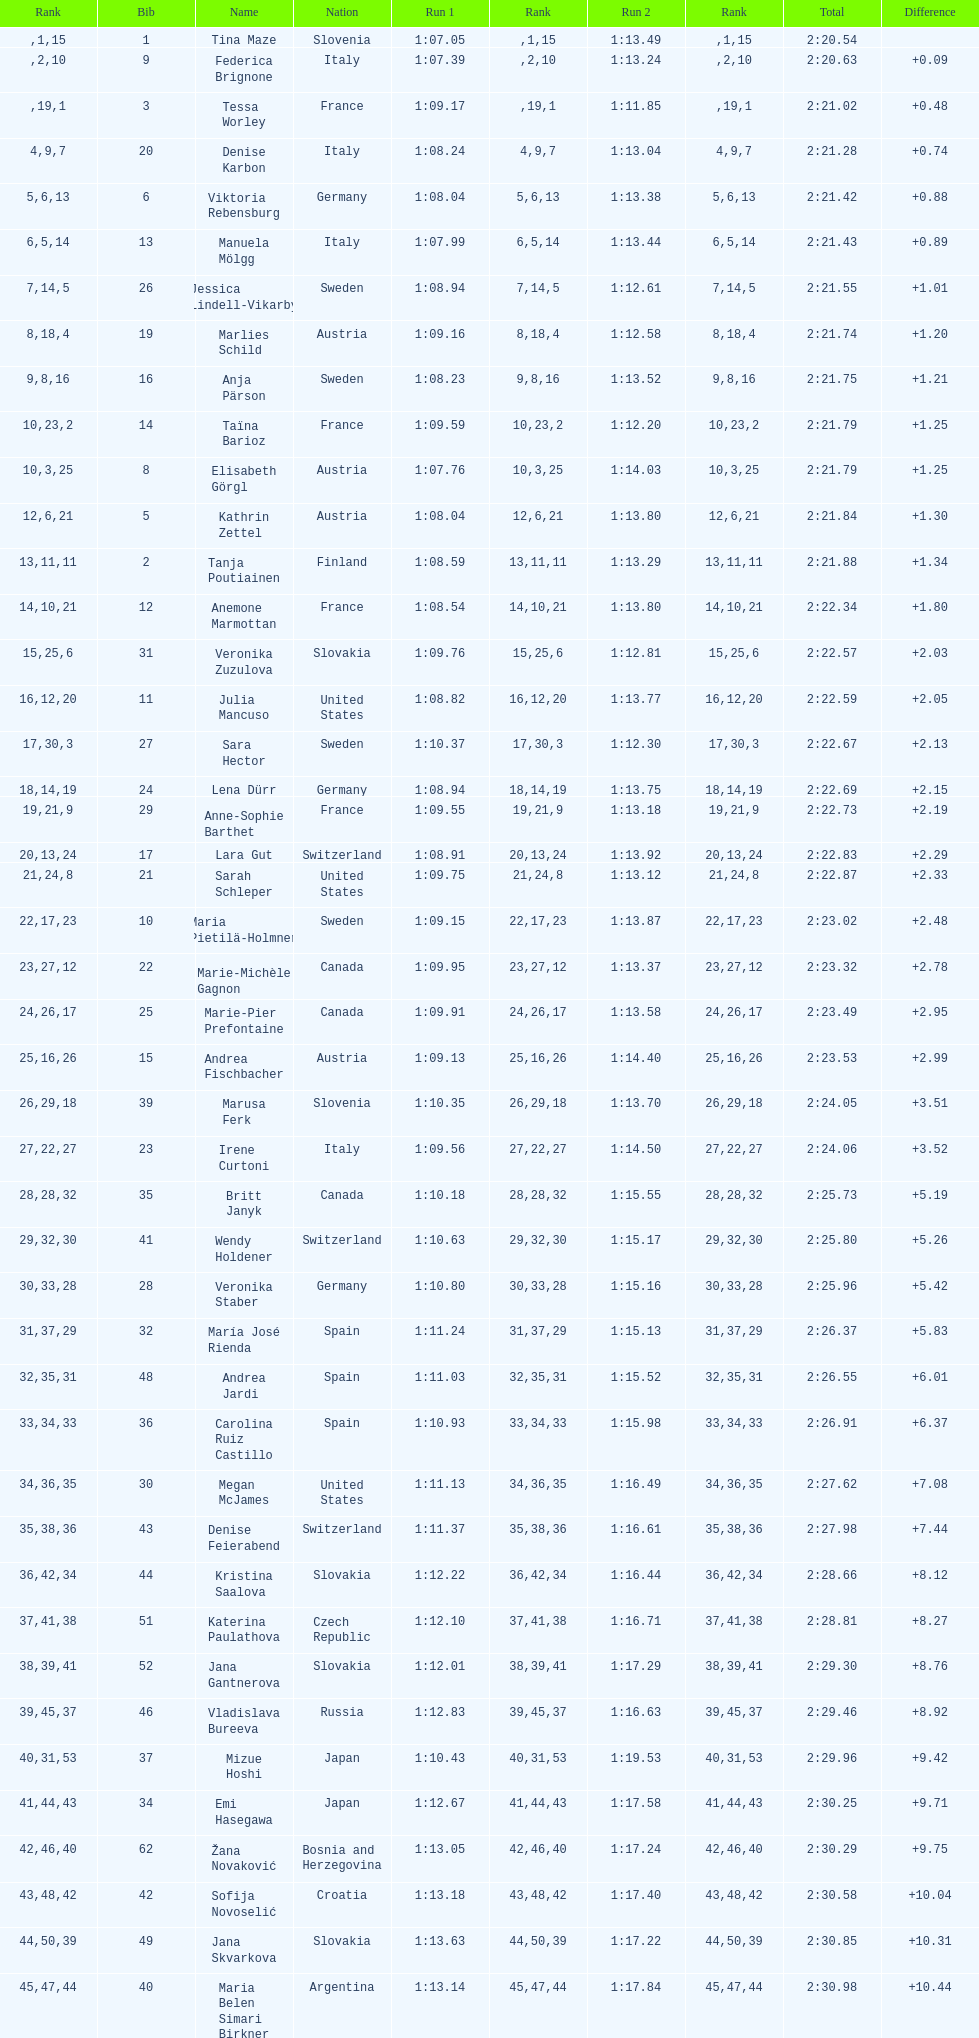Could you help me parse every detail presented in this table? {'header': ['Rank', 'Bib', 'Name', 'Nation', 'Run 1', 'Rank', 'Run 2', 'Rank', 'Total', 'Difference'], 'rows': [['', '1', 'Tina Maze', 'Slovenia', '1:07.05', '1', '1:13.49', '15', '2:20.54', ''], ['', '9', 'Federica Brignone', 'Italy', '1:07.39', '2', '1:13.24', '10', '2:20.63', '+0.09'], ['', '3', 'Tessa Worley', 'France', '1:09.17', '19', '1:11.85', '1', '2:21.02', '+0.48'], ['4', '20', 'Denise Karbon', 'Italy', '1:08.24', '9', '1:13.04', '7', '2:21.28', '+0.74'], ['5', '6', 'Viktoria Rebensburg', 'Germany', '1:08.04', '6', '1:13.38', '13', '2:21.42', '+0.88'], ['6', '13', 'Manuela Mölgg', 'Italy', '1:07.99', '5', '1:13.44', '14', '2:21.43', '+0.89'], ['7', '26', 'Jessica Lindell-Vikarby', 'Sweden', '1:08.94', '14', '1:12.61', '5', '2:21.55', '+1.01'], ['8', '19', 'Marlies Schild', 'Austria', '1:09.16', '18', '1:12.58', '4', '2:21.74', '+1.20'], ['9', '16', 'Anja Pärson', 'Sweden', '1:08.23', '8', '1:13.52', '16', '2:21.75', '+1.21'], ['10', '14', 'Taïna Barioz', 'France', '1:09.59', '23', '1:12.20', '2', '2:21.79', '+1.25'], ['10', '8', 'Elisabeth Görgl', 'Austria', '1:07.76', '3', '1:14.03', '25', '2:21.79', '+1.25'], ['12', '5', 'Kathrin Zettel', 'Austria', '1:08.04', '6', '1:13.80', '21', '2:21.84', '+1.30'], ['13', '2', 'Tanja Poutiainen', 'Finland', '1:08.59', '11', '1:13.29', '11', '2:21.88', '+1.34'], ['14', '12', 'Anemone Marmottan', 'France', '1:08.54', '10', '1:13.80', '21', '2:22.34', '+1.80'], ['15', '31', 'Veronika Zuzulova', 'Slovakia', '1:09.76', '25', '1:12.81', '6', '2:22.57', '+2.03'], ['16', '11', 'Julia Mancuso', 'United States', '1:08.82', '12', '1:13.77', '20', '2:22.59', '+2.05'], ['17', '27', 'Sara Hector', 'Sweden', '1:10.37', '30', '1:12.30', '3', '2:22.67', '+2.13'], ['18', '24', 'Lena Dürr', 'Germany', '1:08.94', '14', '1:13.75', '19', '2:22.69', '+2.15'], ['19', '29', 'Anne-Sophie Barthet', 'France', '1:09.55', '21', '1:13.18', '9', '2:22.73', '+2.19'], ['20', '17', 'Lara Gut', 'Switzerland', '1:08.91', '13', '1:13.92', '24', '2:22.83', '+2.29'], ['21', '21', 'Sarah Schleper', 'United States', '1:09.75', '24', '1:13.12', '8', '2:22.87', '+2.33'], ['22', '10', 'Maria Pietilä-Holmner', 'Sweden', '1:09.15', '17', '1:13.87', '23', '2:23.02', '+2.48'], ['23', '22', 'Marie-Michèle Gagnon', 'Canada', '1:09.95', '27', '1:13.37', '12', '2:23.32', '+2.78'], ['24', '25', 'Marie-Pier Prefontaine', 'Canada', '1:09.91', '26', '1:13.58', '17', '2:23.49', '+2.95'], ['25', '15', 'Andrea Fischbacher', 'Austria', '1:09.13', '16', '1:14.40', '26', '2:23.53', '+2.99'], ['26', '39', 'Marusa Ferk', 'Slovenia', '1:10.35', '29', '1:13.70', '18', '2:24.05', '+3.51'], ['27', '23', 'Irene Curtoni', 'Italy', '1:09.56', '22', '1:14.50', '27', '2:24.06', '+3.52'], ['28', '35', 'Britt Janyk', 'Canada', '1:10.18', '28', '1:15.55', '32', '2:25.73', '+5.19'], ['29', '41', 'Wendy Holdener', 'Switzerland', '1:10.63', '32', '1:15.17', '30', '2:25.80', '+5.26'], ['30', '28', 'Veronika Staber', 'Germany', '1:10.80', '33', '1:15.16', '28', '2:25.96', '+5.42'], ['31', '32', 'María José Rienda', 'Spain', '1:11.24', '37', '1:15.13', '29', '2:26.37', '+5.83'], ['32', '48', 'Andrea Jardi', 'Spain', '1:11.03', '35', '1:15.52', '31', '2:26.55', '+6.01'], ['33', '36', 'Carolina Ruiz Castillo', 'Spain', '1:10.93', '34', '1:15.98', '33', '2:26.91', '+6.37'], ['34', '30', 'Megan McJames', 'United States', '1:11.13', '36', '1:16.49', '35', '2:27.62', '+7.08'], ['35', '43', 'Denise Feierabend', 'Switzerland', '1:11.37', '38', '1:16.61', '36', '2:27.98', '+7.44'], ['36', '44', 'Kristina Saalova', 'Slovakia', '1:12.22', '42', '1:16.44', '34', '2:28.66', '+8.12'], ['37', '51', 'Katerina Paulathova', 'Czech Republic', '1:12.10', '41', '1:16.71', '38', '2:28.81', '+8.27'], ['38', '52', 'Jana Gantnerova', 'Slovakia', '1:12.01', '39', '1:17.29', '41', '2:29.30', '+8.76'], ['39', '46', 'Vladislava Bureeva', 'Russia', '1:12.83', '45', '1:16.63', '37', '2:29.46', '+8.92'], ['40', '37', 'Mizue Hoshi', 'Japan', '1:10.43', '31', '1:19.53', '53', '2:29.96', '+9.42'], ['41', '34', 'Emi Hasegawa', 'Japan', '1:12.67', '44', '1:17.58', '43', '2:30.25', '+9.71'], ['42', '62', 'Žana Novaković', 'Bosnia and Herzegovina', '1:13.05', '46', '1:17.24', '40', '2:30.29', '+9.75'], ['43', '42', 'Sofija Novoselić', 'Croatia', '1:13.18', '48', '1:17.40', '42', '2:30.58', '+10.04'], ['44', '49', 'Jana Skvarkova', 'Slovakia', '1:13.63', '50', '1:17.22', '39', '2:30.85', '+10.31'], ['45', '40', 'Maria Belen Simari Birkner', 'Argentina', '1:13.14', '47', '1:17.84', '44', '2:30.98', '+10.44'], ['46', '50', 'Moe Hanaoka', 'Japan', '1:13.20', '49', '1:18.56', '47', '2:31.76', '+11.22'], ['47', '65', 'Maria Shkanova', 'Belarus', '1:13.86', '53', '1:18.28', '45', '2:32.14', '+11.60'], ['48', '55', 'Katarzyna Karasinska', 'Poland', '1:13.92', '54', '1:18.46', '46', '2:32.38', '+11.84'], ['49', '59', 'Daniela Markova', 'Czech Republic', '1:13.78', '52', '1:18.87', '49', '2:32.65', '+12.11'], ['50', '58', 'Nevena Ignjatović', 'Serbia', '1:14.38', '58', '1:18.56', '47', '2:32.94', '+12.40'], ['51', '80', 'Maria Kirkova', 'Bulgaria', '1:13.70', '51', '1:19.56', '54', '2:33.26', '+12.72'], ['52', '77', 'Bogdana Matsotska', 'Ukraine', '1:14.21', '56', '1:19.18', '51', '2:33.39', '+12.85'], ['53', '68', 'Zsofia Doeme', 'Hungary', '1:14.57', '59', '1:18.93', '50', '2:33.50', '+12.96'], ['54', '56', 'Anna-Laura Bühler', 'Liechtenstein', '1:14.22', '57', '1:19.36', '52', '2:33.58', '+13.04'], ['55', '67', 'Martina Dubovska', 'Czech Republic', '1:14.62', '60', '1:19.95', '55', '2:34.57', '+14.03'], ['', '7', 'Kathrin Hölzl', 'Germany', '1:09.41', '20', 'DNS', '', '', ''], ['', '4', 'Maria Riesch', 'Germany', '1:07.86', '4', 'DNF', '', '', ''], ['', '38', 'Rebecca Bühler', 'Liechtenstein', '1:12.03', '40', 'DNF', '', '', ''], ['', '47', 'Vanessa Schädler', 'Liechtenstein', '1:12.47', '43', 'DNF', '', '', ''], ['', '69', 'Iris Gudmundsdottir', 'Iceland', '1:13.93', '55', 'DNF', '', '', ''], ['', '45', 'Tea Palić', 'Croatia', '1:14.73', '61', 'DNQ', '', '', ''], ['', '74', 'Macarena Simari Birkner', 'Argentina', '1:15.18', '62', 'DNQ', '', '', ''], ['', '72', 'Lavinia Chrystal', 'Australia', '1:15.35', '63', 'DNQ', '', '', ''], ['', '81', 'Lelde Gasuna', 'Latvia', '1:15.37', '64', 'DNQ', '', '', ''], ['', '64', 'Aleksandra Klus', 'Poland', '1:15.41', '65', 'DNQ', '', '', ''], ['', '78', 'Nino Tsiklauri', 'Georgia', '1:15.54', '66', 'DNQ', '', '', ''], ['', '66', 'Sarah Jarvis', 'New Zealand', '1:15.94', '67', 'DNQ', '', '', ''], ['', '61', 'Anna Berecz', 'Hungary', '1:15.95', '68', 'DNQ', '', '', ''], ['', '83', 'Sandra-Elena Narea', 'Romania', '1:16.67', '69', 'DNQ', '', '', ''], ['', '85', 'Iulia Petruta Craciun', 'Romania', '1:16.80', '70', 'DNQ', '', '', ''], ['', '82', 'Isabel van Buynder', 'Belgium', '1:17.06', '71', 'DNQ', '', '', ''], ['', '97', 'Liene Fimbauere', 'Latvia', '1:17.83', '72', 'DNQ', '', '', ''], ['', '86', 'Kristina Krone', 'Puerto Rico', '1:17.93', '73', 'DNQ', '', '', ''], ['', '88', 'Nicole Valcareggi', 'Greece', '1:18.19', '74', 'DNQ', '', '', ''], ['', '100', 'Sophie Fjellvang-Sølling', 'Denmark', '1:18.37', '75', 'DNQ', '', '', ''], ['', '95', 'Ornella Oettl Reyes', 'Peru', '1:18.61', '76', 'DNQ', '', '', ''], ['', '73', 'Xia Lina', 'China', '1:19.12', '77', 'DNQ', '', '', ''], ['', '94', 'Kseniya Grigoreva', 'Uzbekistan', '1:19.16', '78', 'DNQ', '', '', ''], ['', '87', 'Tugba Dasdemir', 'Turkey', '1:21.50', '79', 'DNQ', '', '', ''], ['', '92', 'Malene Madsen', 'Denmark', '1:22.25', '80', 'DNQ', '', '', ''], ['', '84', 'Liu Yang', 'China', '1:22.80', '81', 'DNQ', '', '', ''], ['', '91', 'Yom Hirshfeld', 'Israel', '1:22.87', '82', 'DNQ', '', '', ''], ['', '75', 'Salome Bancora', 'Argentina', '1:23.08', '83', 'DNQ', '', '', ''], ['', '93', 'Ronnie Kiek-Gedalyahu', 'Israel', '1:23.38', '84', 'DNQ', '', '', ''], ['', '96', 'Chiara Marano', 'Brazil', '1:24.16', '85', 'DNQ', '', '', ''], ['', '113', 'Anne Libak Nielsen', 'Denmark', '1:25.08', '86', 'DNQ', '', '', ''], ['', '105', 'Donata Hellner', 'Hungary', '1:26.97', '87', 'DNQ', '', '', ''], ['', '102', 'Liu Yu', 'China', '1:27.03', '88', 'DNQ', '', '', ''], ['', '109', 'Lida Zvoznikova', 'Kyrgyzstan', '1:27.17', '89', 'DNQ', '', '', ''], ['', '103', 'Szelina Hellner', 'Hungary', '1:27.27', '90', 'DNQ', '', '', ''], ['', '114', 'Irina Volkova', 'Kyrgyzstan', '1:29.73', '91', 'DNQ', '', '', ''], ['', '106', 'Svetlana Baranova', 'Uzbekistan', '1:30.62', '92', 'DNQ', '', '', ''], ['', '108', 'Tatjana Baranova', 'Uzbekistan', '1:31.81', '93', 'DNQ', '', '', ''], ['', '110', 'Fatemeh Kiadarbandsari', 'Iran', '1:32.16', '94', 'DNQ', '', '', ''], ['', '107', 'Ziba Kalhor', 'Iran', '1:32.64', '95', 'DNQ', '', '', ''], ['', '104', 'Paraskevi Mavridou', 'Greece', '1:32.83', '96', 'DNQ', '', '', ''], ['', '99', 'Marjan Kalhor', 'Iran', '1:34.94', '97', 'DNQ', '', '', ''], ['', '112', 'Mitra Kalhor', 'Iran', '1:37.93', '98', 'DNQ', '', '', ''], ['', '115', 'Laura Bauer', 'South Africa', '1:42.19', '99', 'DNQ', '', '', ''], ['', '111', 'Sarah Ekmekejian', 'Lebanon', '1:42.22', '100', 'DNQ', '', '', ''], ['', '18', 'Fabienne Suter', 'Switzerland', 'DNS', '', '', '', '', ''], ['', '98', 'Maja Klepić', 'Bosnia and Herzegovina', 'DNS', '', '', '', '', ''], ['', '33', 'Agniezska Gasienica Daniel', 'Poland', 'DNF', '', '', '', '', ''], ['', '53', 'Karolina Chrapek', 'Poland', 'DNF', '', '', '', '', ''], ['', '54', 'Mireia Gutierrez', 'Andorra', 'DNF', '', '', '', '', ''], ['', '57', 'Brittany Phelan', 'Canada', 'DNF', '', '', '', '', ''], ['', '60', 'Tereza Kmochova', 'Czech Republic', 'DNF', '', '', '', '', ''], ['', '63', 'Michelle van Herwerden', 'Netherlands', 'DNF', '', '', '', '', ''], ['', '70', 'Maya Harrisson', 'Brazil', 'DNF', '', '', '', '', ''], ['', '71', 'Elizabeth Pilat', 'Australia', 'DNF', '', '', '', '', ''], ['', '76', 'Katrin Kristjansdottir', 'Iceland', 'DNF', '', '', '', '', ''], ['', '79', 'Julietta Quiroga', 'Argentina', 'DNF', '', '', '', '', ''], ['', '89', 'Evija Benhena', 'Latvia', 'DNF', '', '', '', '', ''], ['', '90', 'Qin Xiyue', 'China', 'DNF', '', '', '', '', ''], ['', '101', 'Sophia Ralli', 'Greece', 'DNF', '', '', '', '', ''], ['', '116', 'Siranush Maghakyan', 'Armenia', 'DNF', '', '', '', '', '']]} How many athletes had the same rank for both run 1 and run 2? 1. 